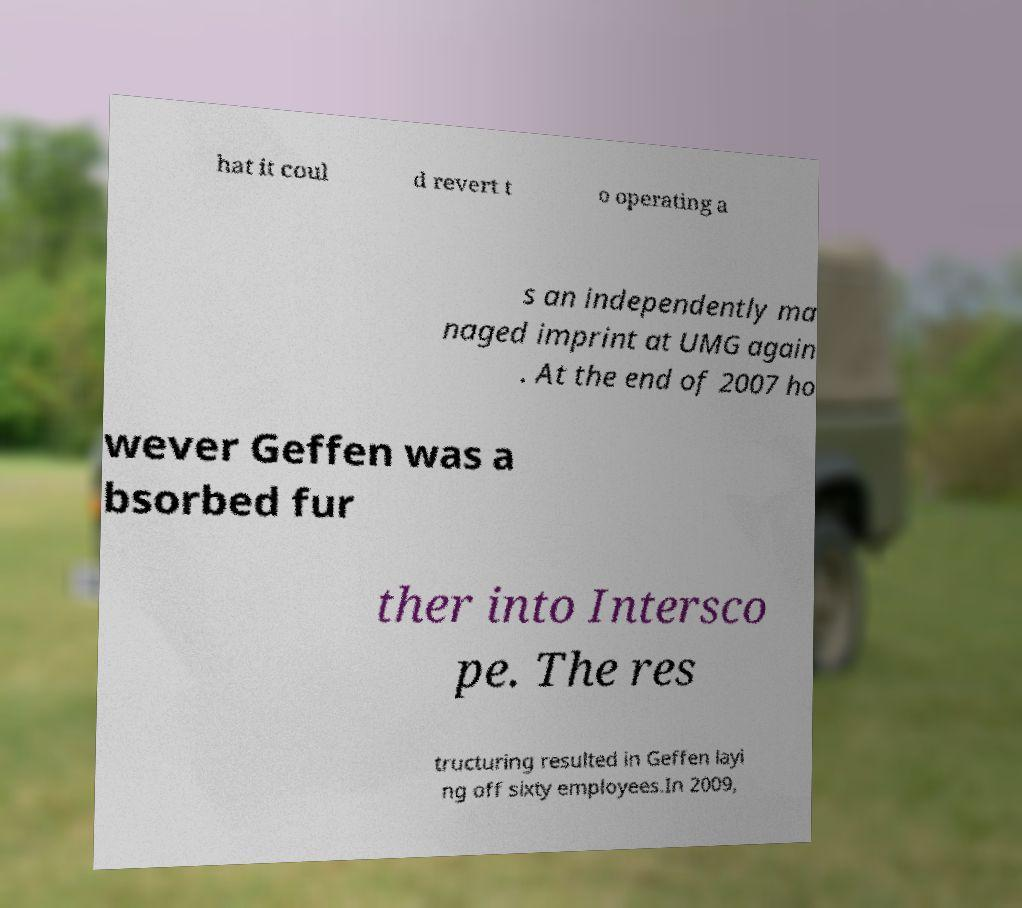What messages or text are displayed in this image? I need them in a readable, typed format. hat it coul d revert t o operating a s an independently ma naged imprint at UMG again . At the end of 2007 ho wever Geffen was a bsorbed fur ther into Intersco pe. The res tructuring resulted in Geffen layi ng off sixty employees.In 2009, 